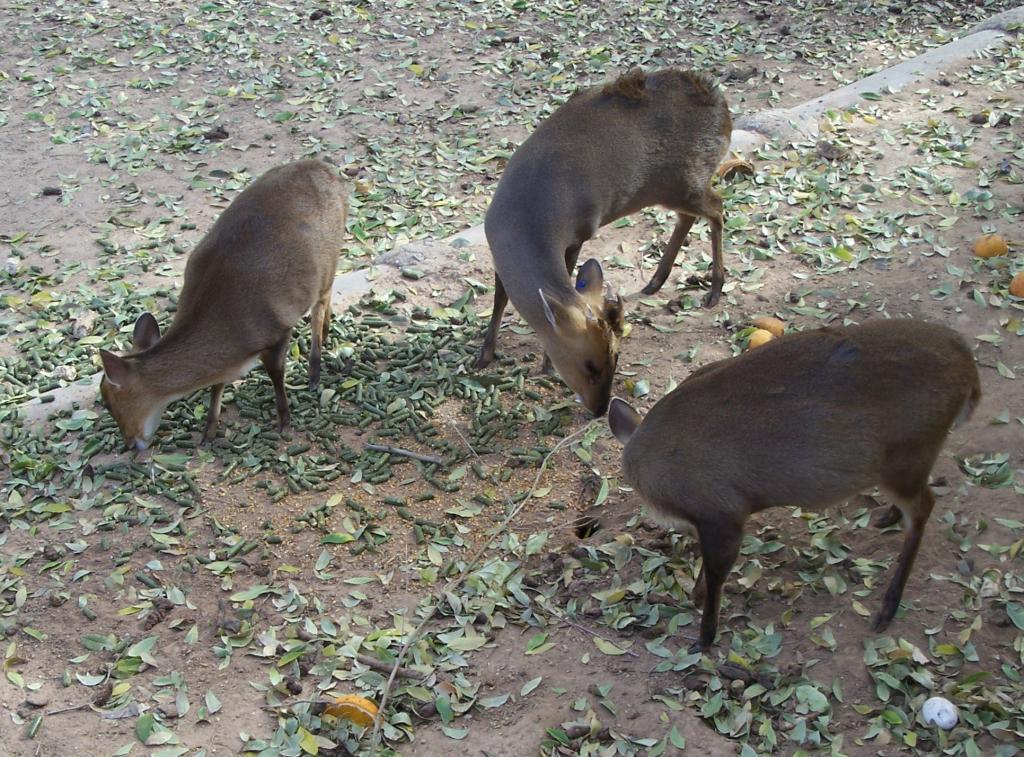Could you give a brief overview of what you see in this image? In this image I can see the ground, few leaves on the ground, a pipe and three animals which are brown in color are standing on the ground. 